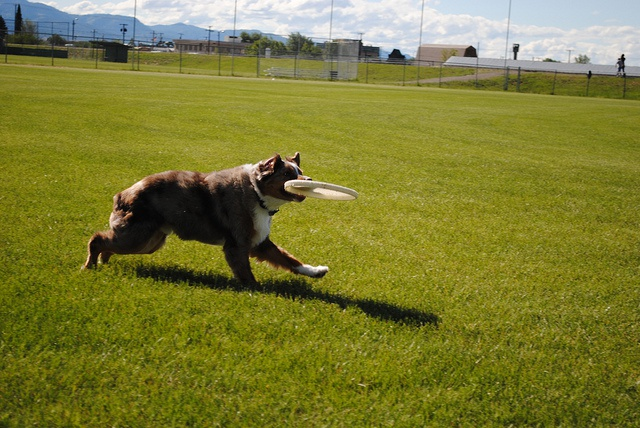Describe the objects in this image and their specific colors. I can see dog in gray, black, olive, tan, and maroon tones, frisbee in gray, tan, and ivory tones, people in gray and black tones, and people in gray and black tones in this image. 